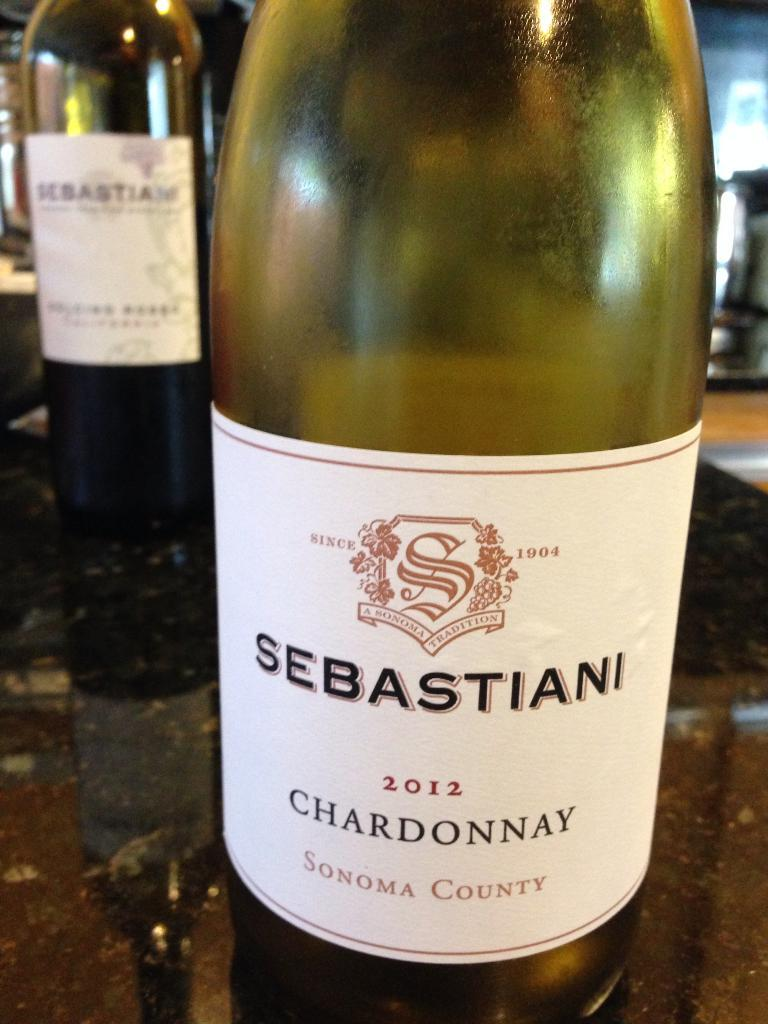<image>
Create a compact narrative representing the image presented. Green bottle of sebastiani chardonnay sonoma county wine 